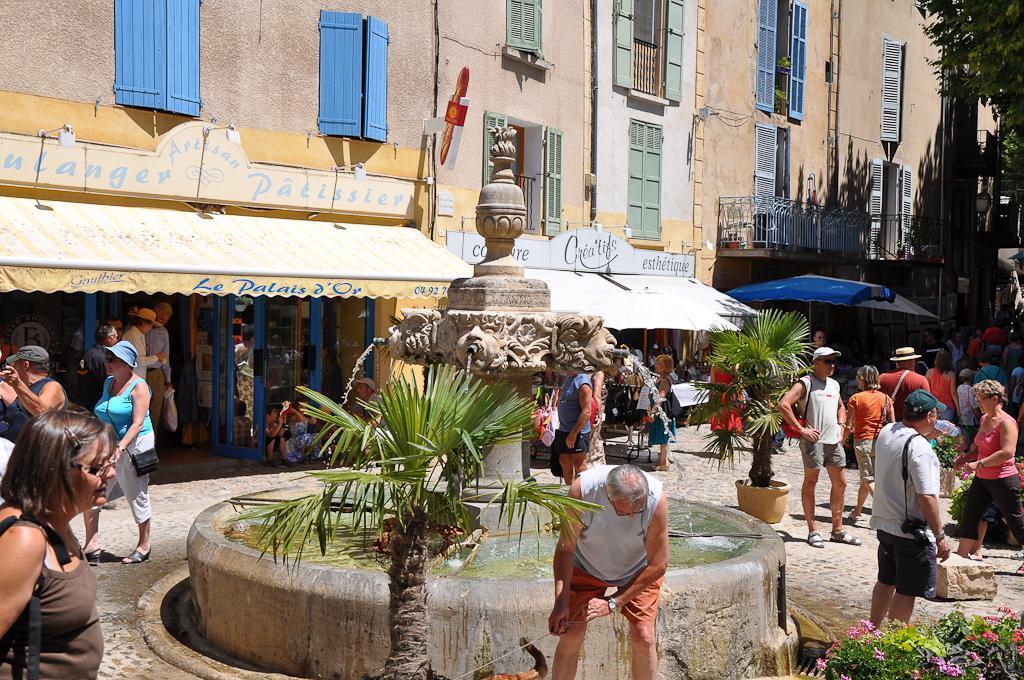How would you summarize this image in a sentence or two? In this picture there are group of people and there are buildings and trees and there are umbrellas. In the foreground there is a fountain and there are plants and there are boards on the buildings and there is text on the boards. At the bottom there is a road and there are flowers. 